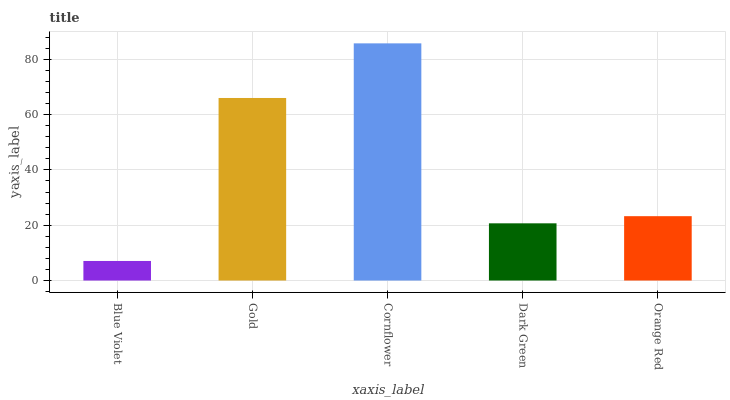Is Blue Violet the minimum?
Answer yes or no. Yes. Is Cornflower the maximum?
Answer yes or no. Yes. Is Gold the minimum?
Answer yes or no. No. Is Gold the maximum?
Answer yes or no. No. Is Gold greater than Blue Violet?
Answer yes or no. Yes. Is Blue Violet less than Gold?
Answer yes or no. Yes. Is Blue Violet greater than Gold?
Answer yes or no. No. Is Gold less than Blue Violet?
Answer yes or no. No. Is Orange Red the high median?
Answer yes or no. Yes. Is Orange Red the low median?
Answer yes or no. Yes. Is Dark Green the high median?
Answer yes or no. No. Is Dark Green the low median?
Answer yes or no. No. 